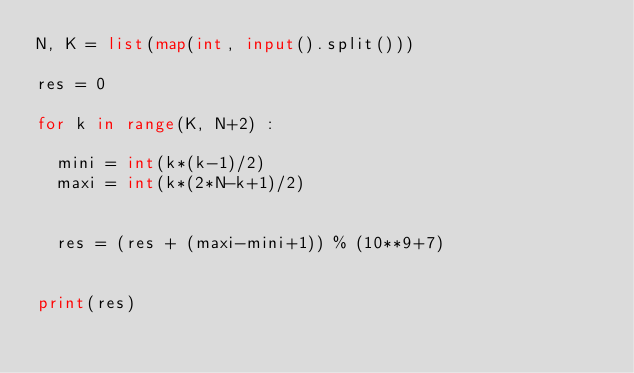Convert code to text. <code><loc_0><loc_0><loc_500><loc_500><_Python_>N, K = list(map(int, input().split()))

res = 0

for k in range(K, N+2) :

  mini = int(k*(k-1)/2)
  maxi = int(k*(2*N-k+1)/2)

    
  res = (res + (maxi-mini+1)) % (10**9+7)

  
print(res)</code> 